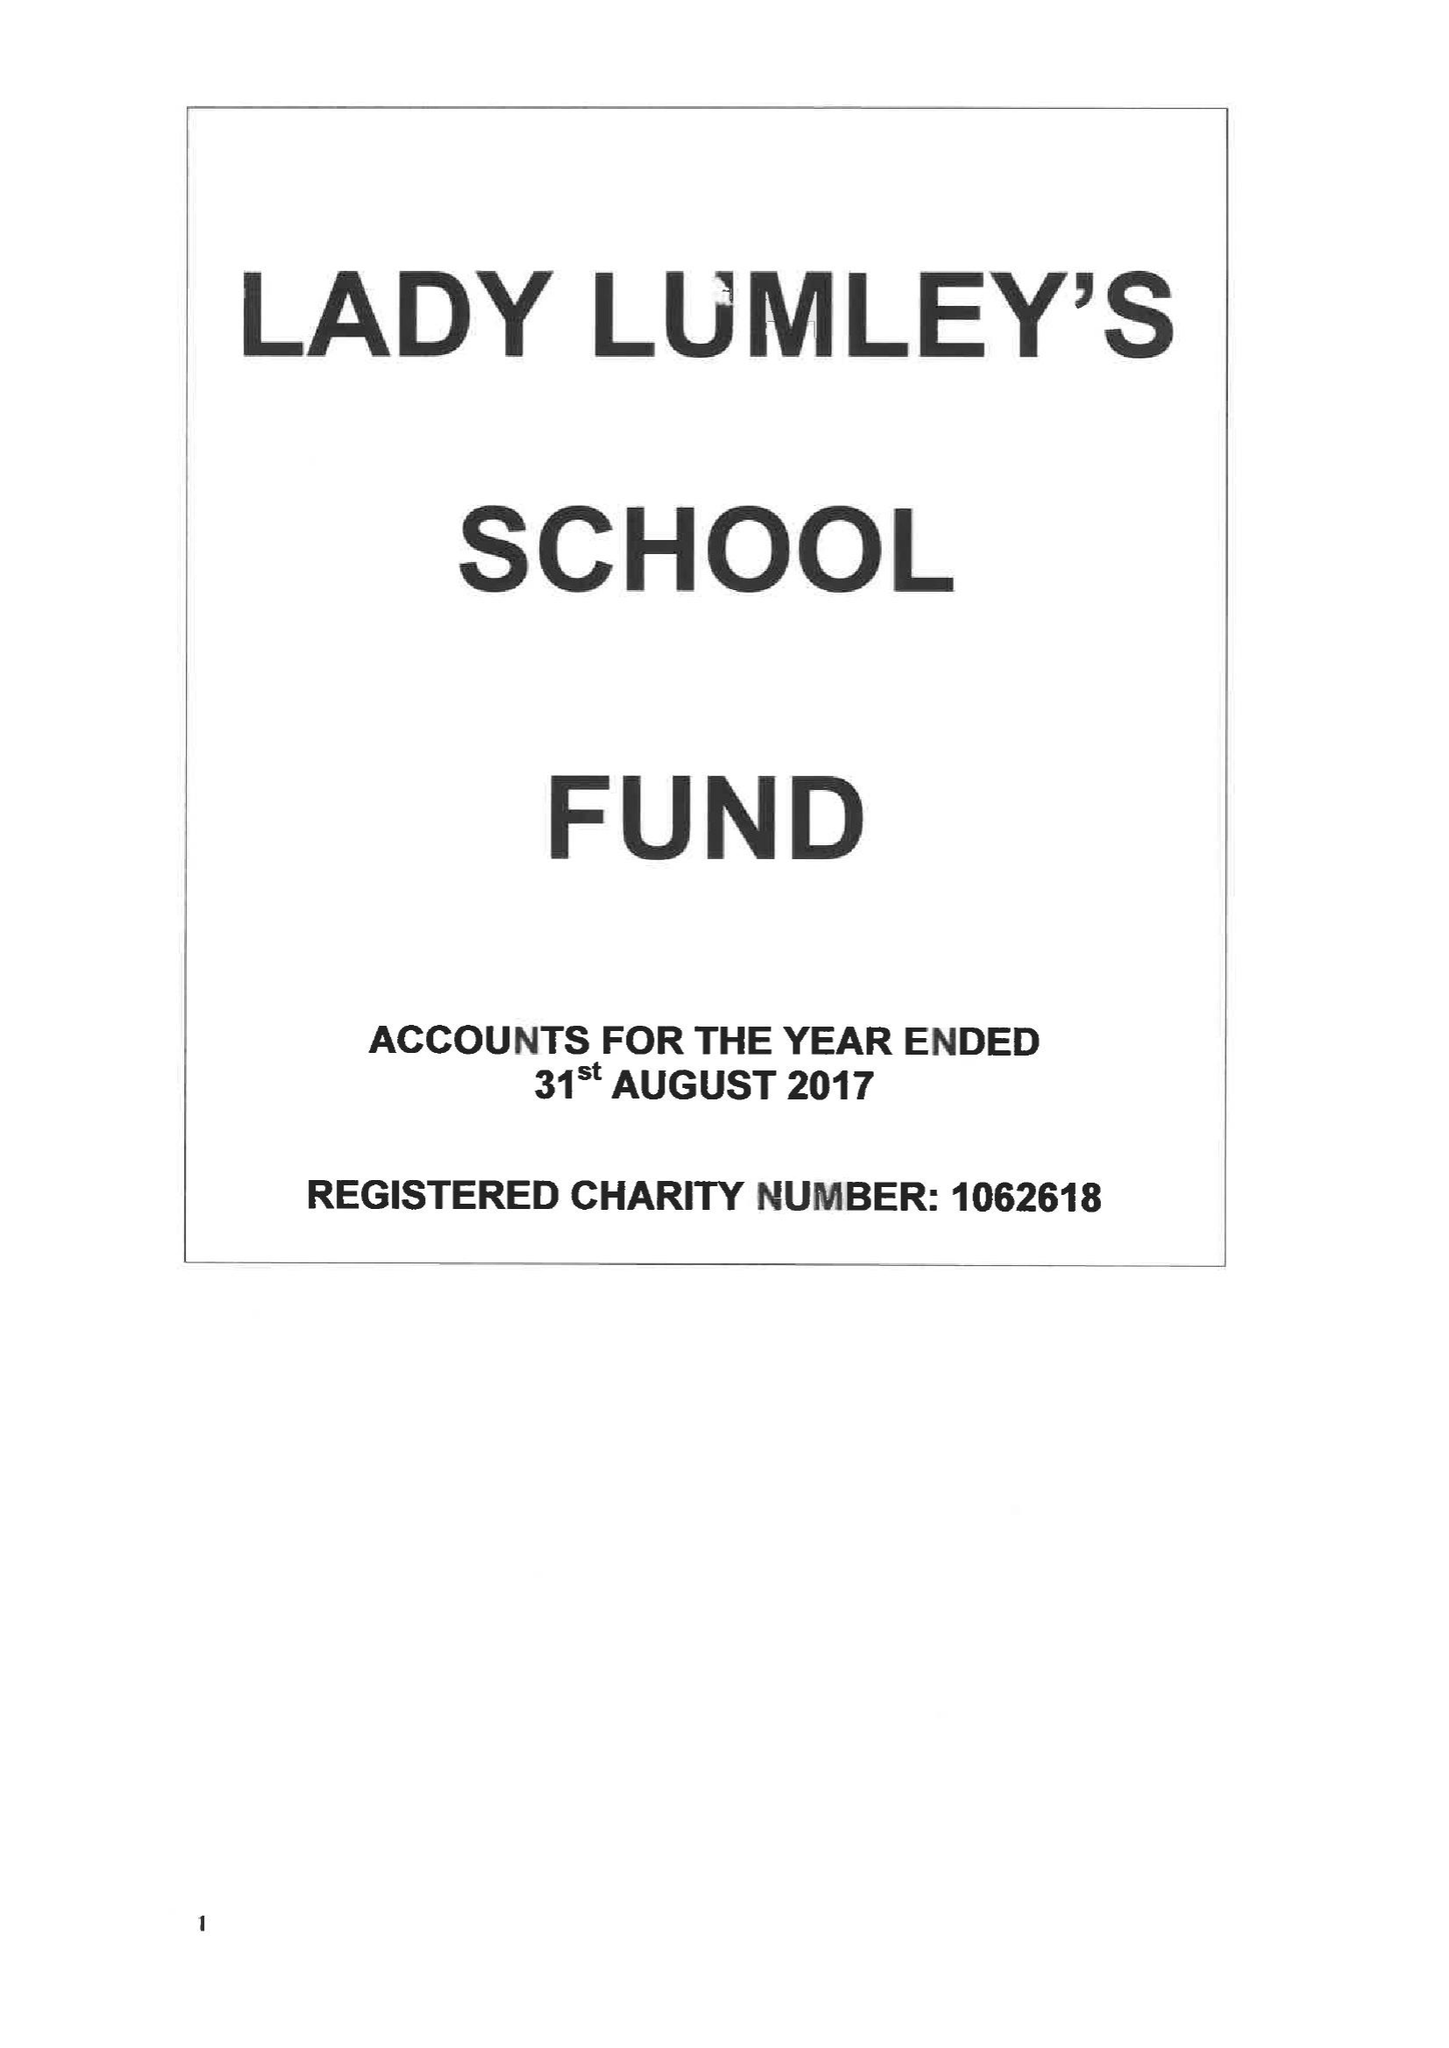What is the value for the address__postcode?
Answer the question using a single word or phrase. YO18 8NG 